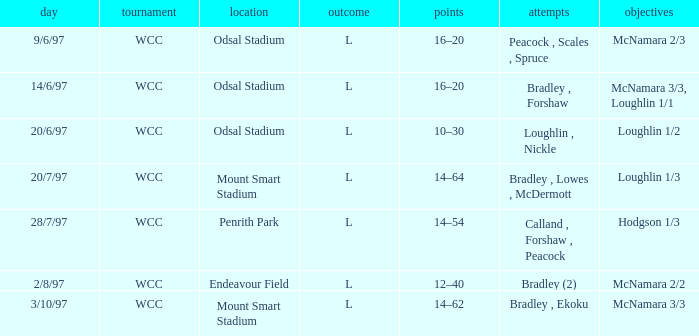What were the tries on 14/6/97? Bradley , Forshaw. 